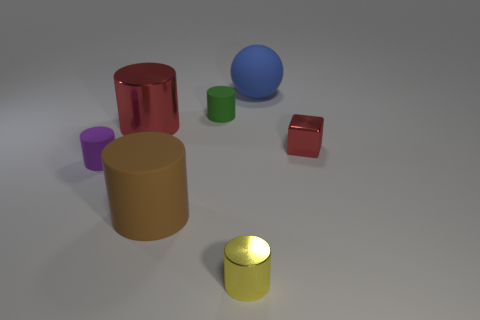Subtract all green rubber cylinders. How many cylinders are left? 4 Add 1 big brown rubber things. How many objects exist? 8 Subtract all red cylinders. How many cylinders are left? 4 Subtract all large green things. Subtract all red metal cylinders. How many objects are left? 6 Add 6 brown matte cylinders. How many brown matte cylinders are left? 7 Add 5 brown rubber cylinders. How many brown rubber cylinders exist? 6 Subtract 0 yellow balls. How many objects are left? 7 Subtract all balls. How many objects are left? 6 Subtract 5 cylinders. How many cylinders are left? 0 Subtract all cyan cylinders. Subtract all green balls. How many cylinders are left? 5 